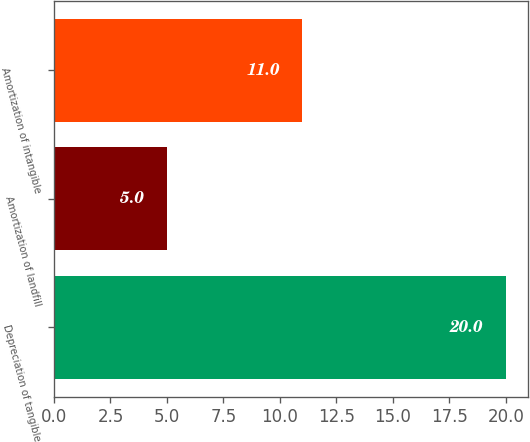<chart> <loc_0><loc_0><loc_500><loc_500><bar_chart><fcel>Depreciation of tangible<fcel>Amortization of landfill<fcel>Amortization of intangible<nl><fcel>20<fcel>5<fcel>11<nl></chart> 